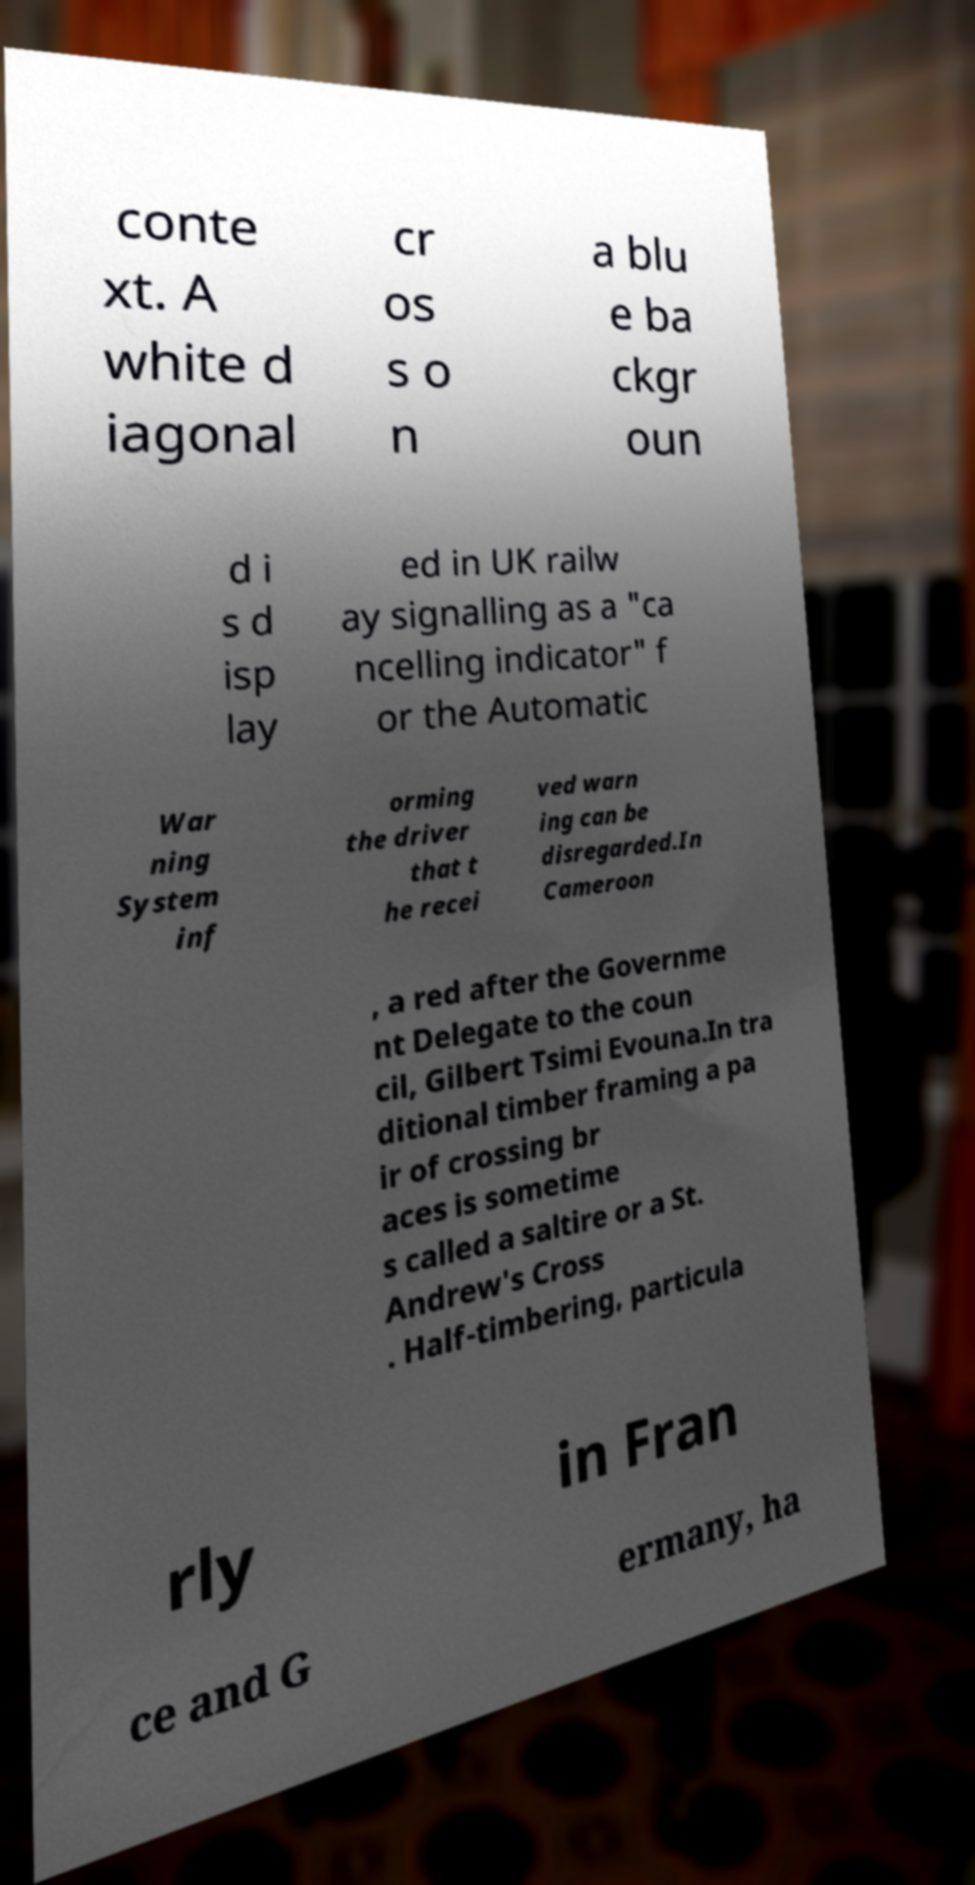There's text embedded in this image that I need extracted. Can you transcribe it verbatim? conte xt. A white d iagonal cr os s o n a blu e ba ckgr oun d i s d isp lay ed in UK railw ay signalling as a "ca ncelling indicator" f or the Automatic War ning System inf orming the driver that t he recei ved warn ing can be disregarded.In Cameroon , a red after the Governme nt Delegate to the coun cil, Gilbert Tsimi Evouna.In tra ditional timber framing a pa ir of crossing br aces is sometime s called a saltire or a St. Andrew's Cross . Half-timbering, particula rly in Fran ce and G ermany, ha 